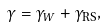<formula> <loc_0><loc_0><loc_500><loc_500>\gamma = \gamma _ { W } + \gamma _ { \text {RS} } ,</formula> 